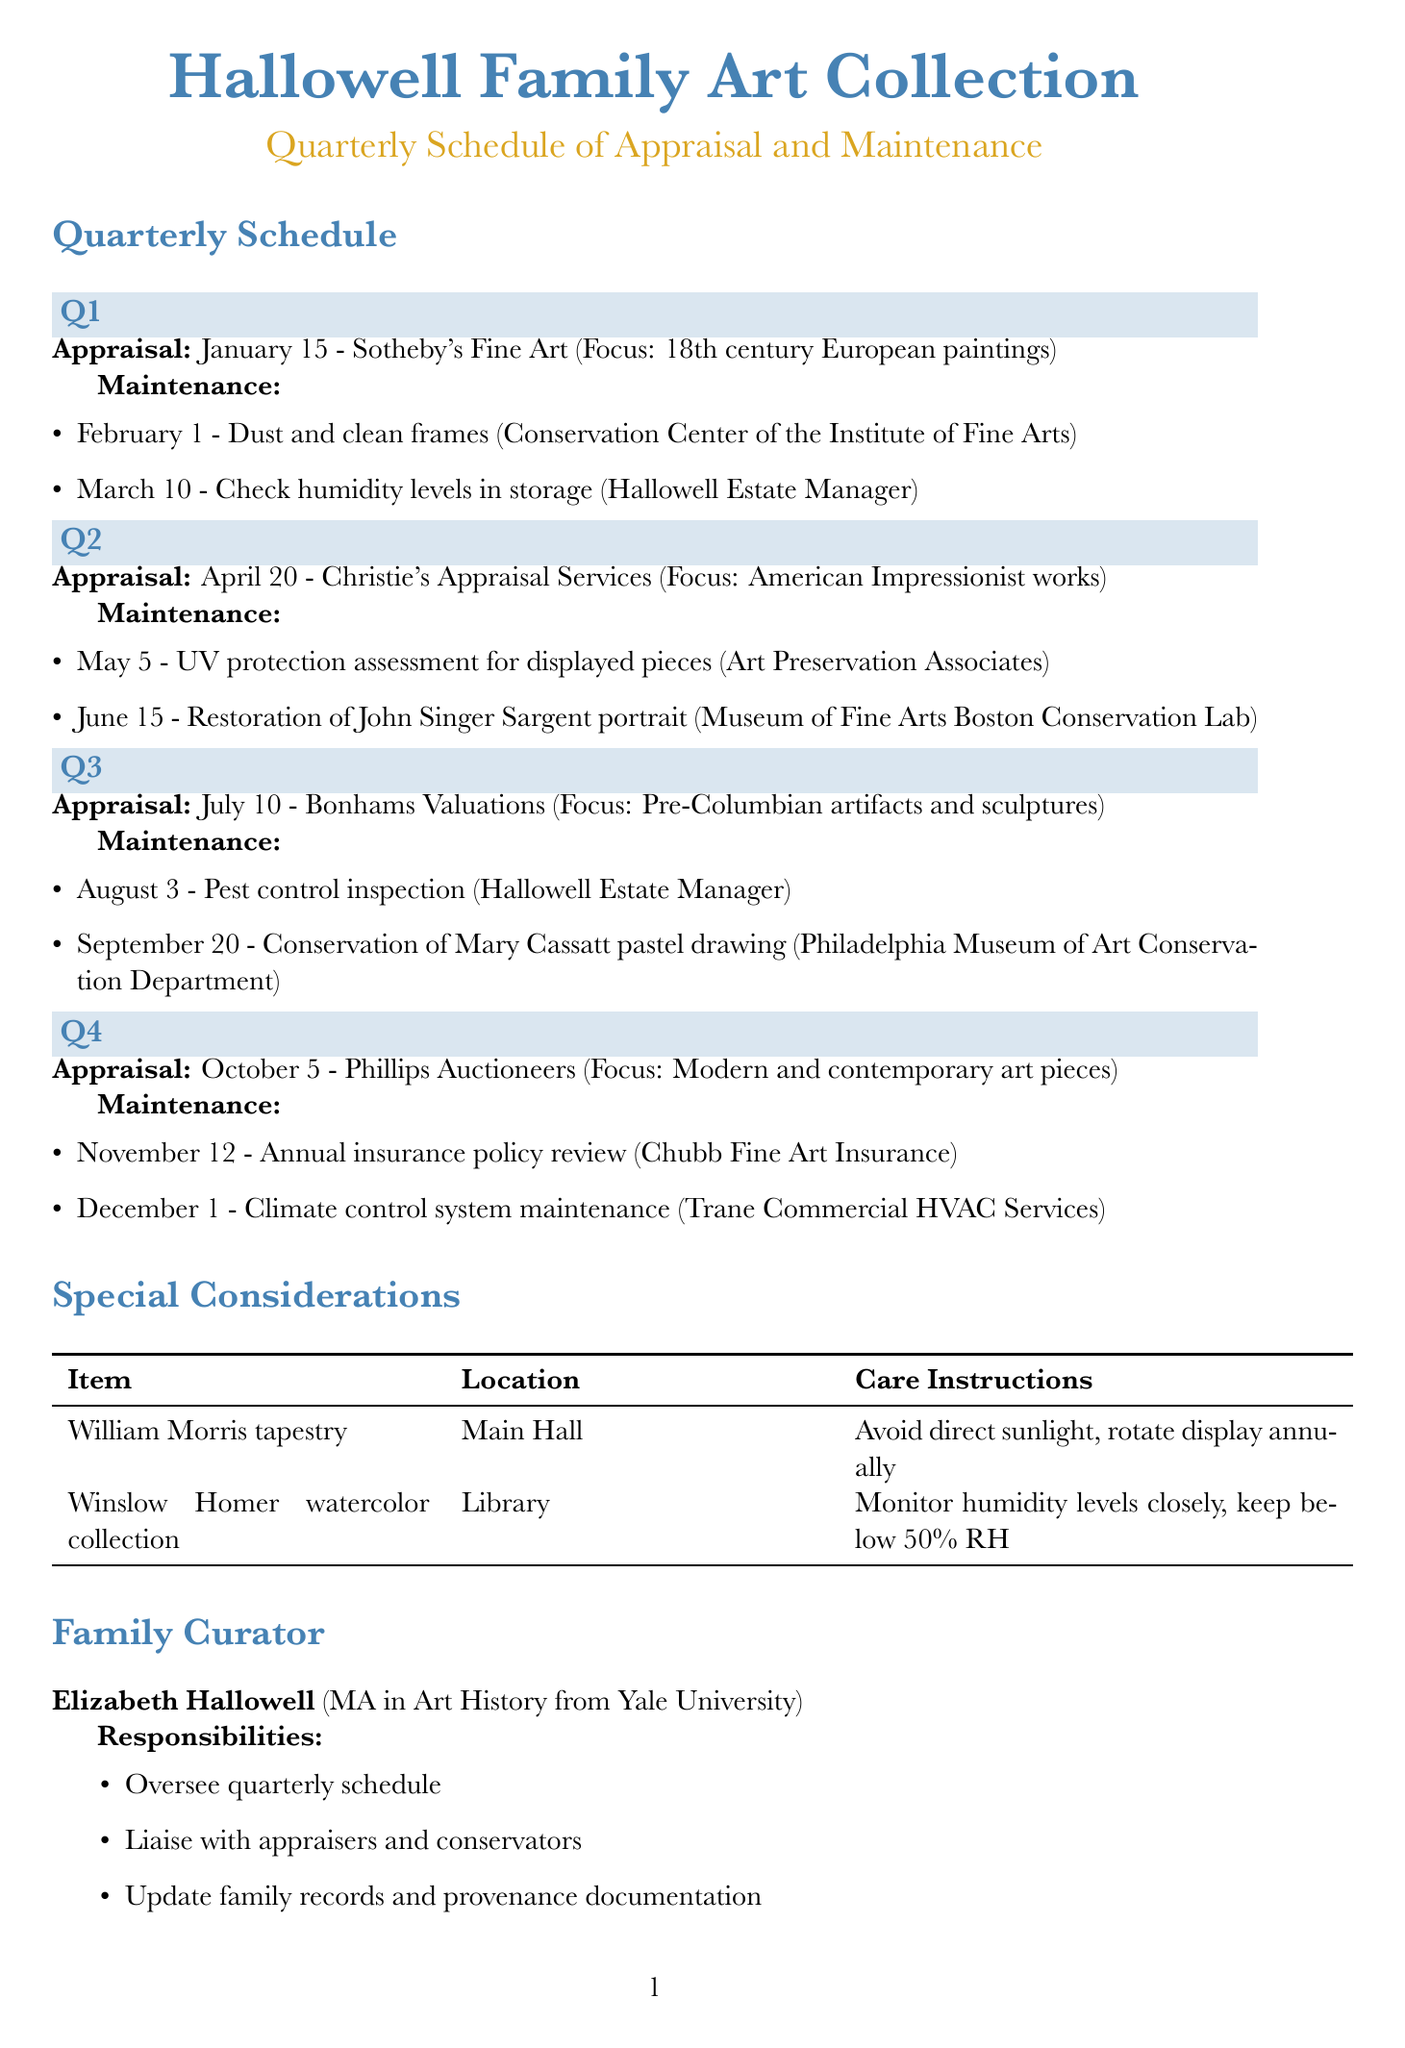What is the name of the family art collection? The name of the art collection is stated at the beginning of the document.
Answer: Hallowell Family Art Collection Who is responsible for the February maintenance task? The responsible party for the maintenance task on February 1 is listed in the document under Q1.
Answer: Conservation Center of the Institute of Fine Arts What is the date of the appraisal in Q3? The date of the appraisal in Q3 is explicitly mentioned in the quarterly schedule section of the document.
Answer: July 10 Which appraiser is scheduled for the Q2 appraisal? The appraiser scheduled for the Q2 appraisal is found in the Q2 section of the quarterly schedule.
Answer: Christie's Appraisal Services What task is scheduled for December 1? The task scheduled for December 1 is clearly specified in the Q4 maintenance section of the document.
Answer: Climate control system maintenance What is the focus of the appraisal in Q4? The focus of the Q4 appraisal is directly stated in the quarterly schedule for that quarter.
Answer: Modern and contemporary art pieces How many maintenance tasks are planned for Q3? The total number of maintenance tasks in Q3 can be counted from the Q3 maintenance list provided in the document.
Answer: 2 What chart lists special care instructions? The care instructions for special items are listed in a table under the special considerations section of the document.
Answer: Special Considerations 